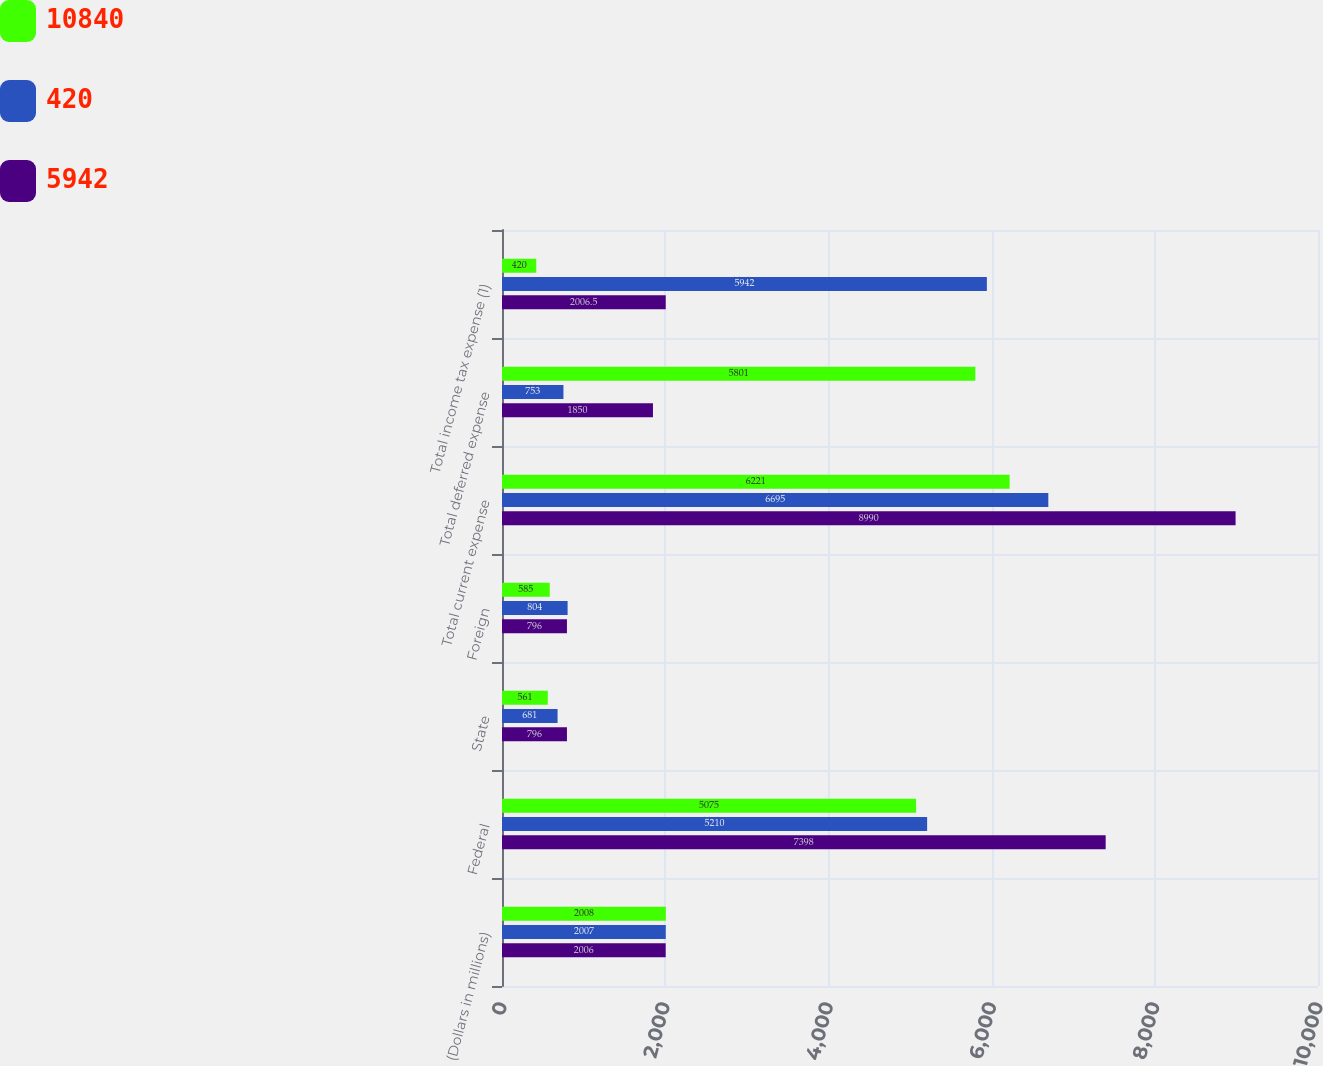Convert chart. <chart><loc_0><loc_0><loc_500><loc_500><stacked_bar_chart><ecel><fcel>(Dollars in millions)<fcel>Federal<fcel>State<fcel>Foreign<fcel>Total current expense<fcel>Total deferred expense<fcel>Total income tax expense (1)<nl><fcel>10840<fcel>2008<fcel>5075<fcel>561<fcel>585<fcel>6221<fcel>5801<fcel>420<nl><fcel>420<fcel>2007<fcel>5210<fcel>681<fcel>804<fcel>6695<fcel>753<fcel>5942<nl><fcel>5942<fcel>2006<fcel>7398<fcel>796<fcel>796<fcel>8990<fcel>1850<fcel>2006.5<nl></chart> 